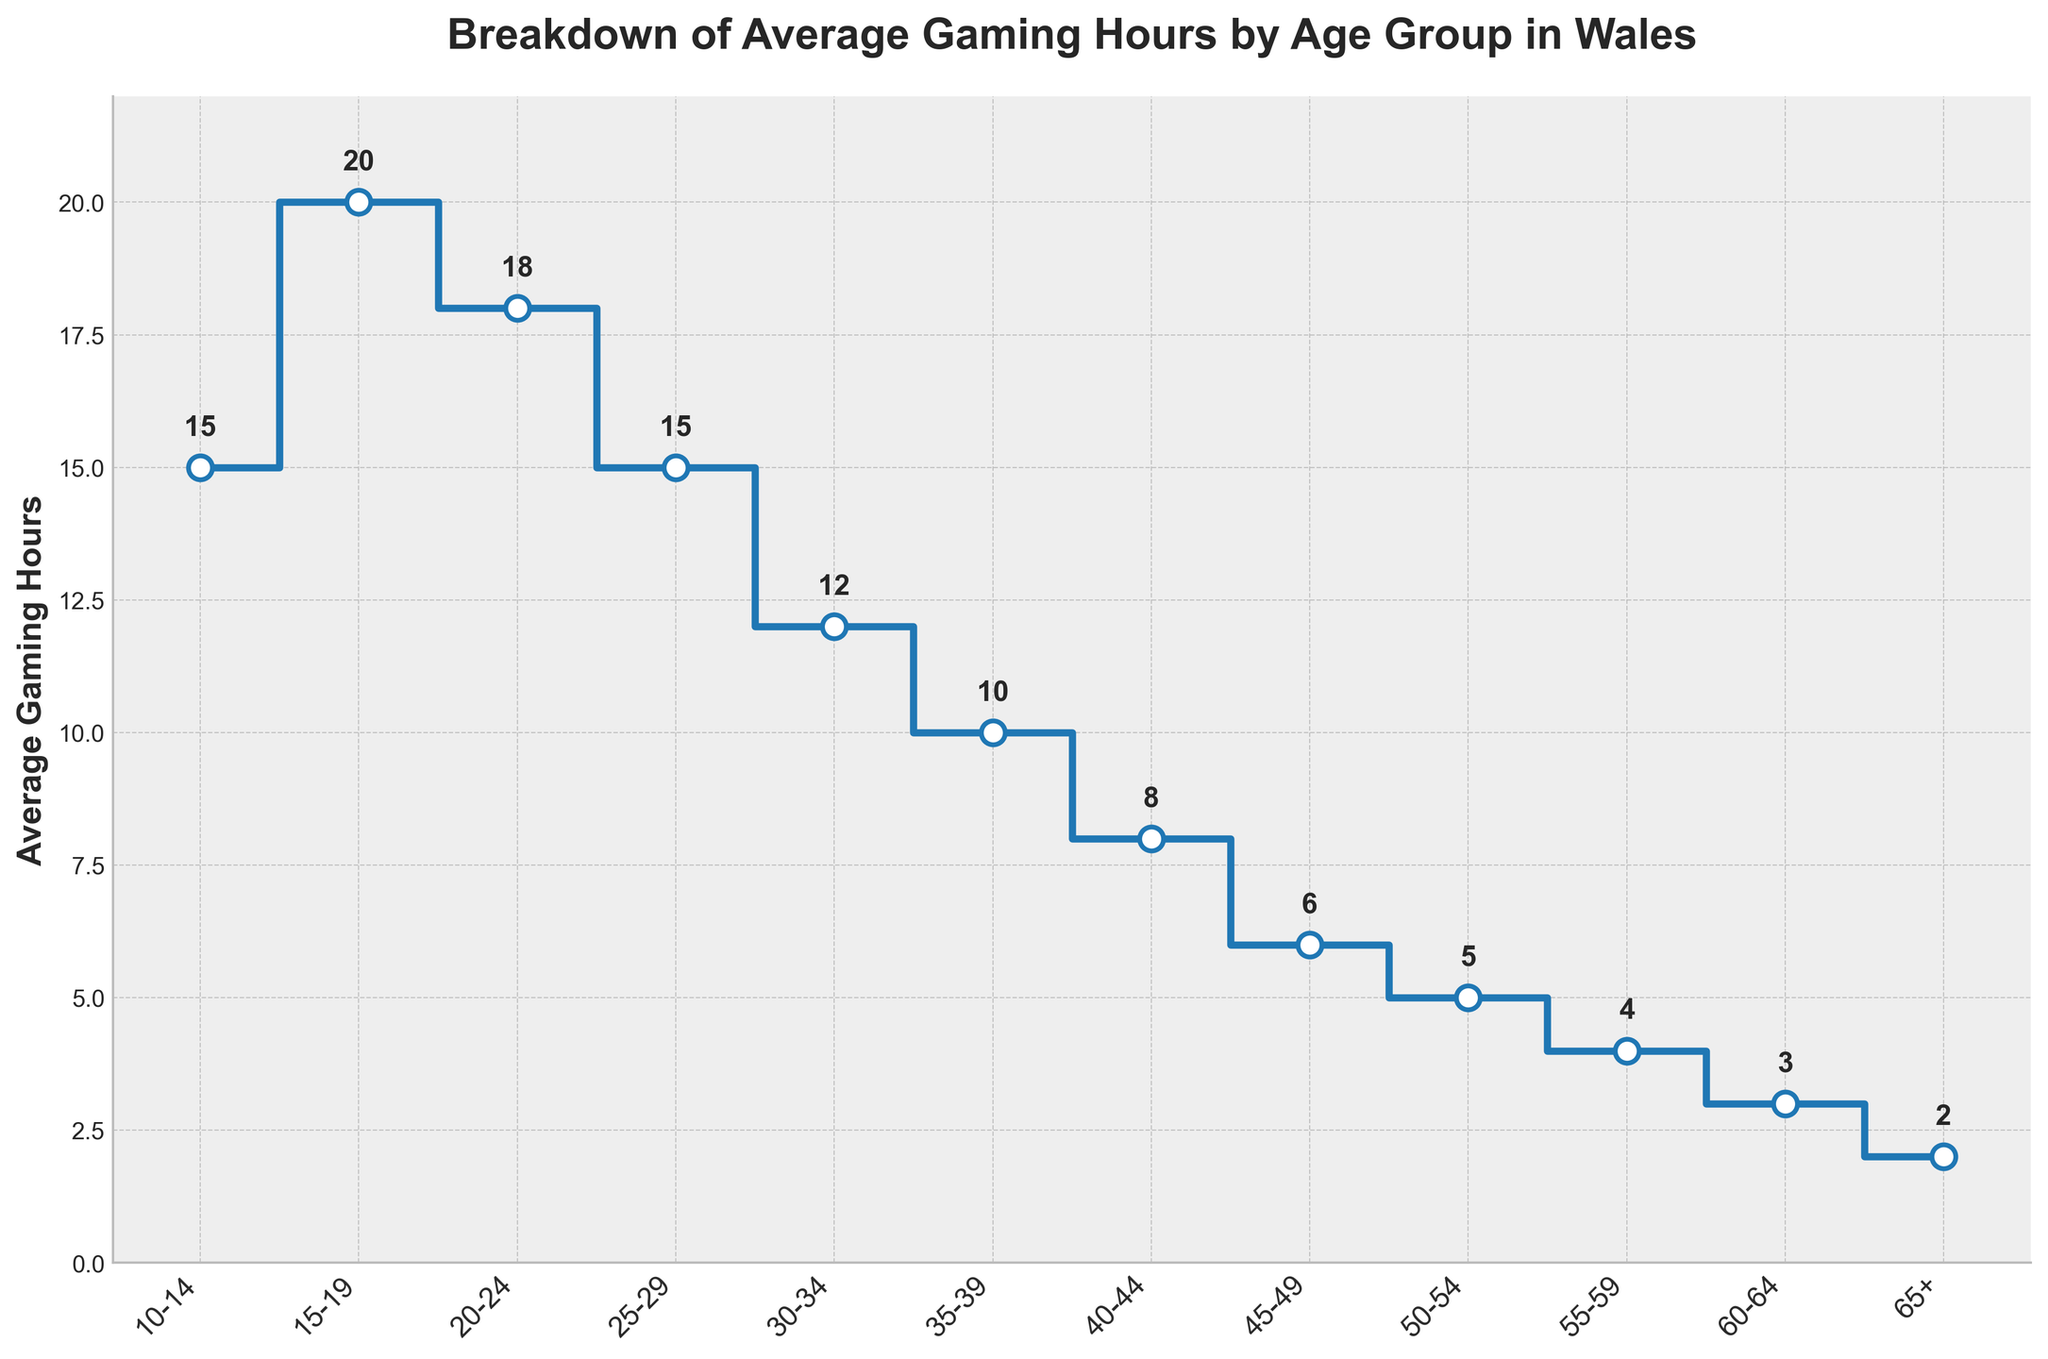What is the title of the plot? The title is usually found at the top of the plot and summarizes what the plot is about. From visual inspection, the title is "Breakdown of Average Gaming Hours by Age Group in Wales".
Answer: Breakdown of Average Gaming Hours by Age Group in Wales What is the maximum average gaming hours, and which age group does it correspond to? To find this, look at the highest point on the y-axis and trace it to the corresponding age group on the x-axis. The maximum value is 20 hours for the age group 15-19.
Answer: 20, 15-19 Which age group has the lowest average gaming hours? Look for the lowest data point on the y-axis and identify the corresponding age group on the x-axis. The lowest point is 2 hours for the age group 65+.
Answer: 65+ What is the difference in average gaming hours between the age groups 20-24 and 30-34? Look for the values corresponding to the age groups 20-24 and 30-34. The average gaming hours for 20-24 is 18 and for 30-34 is 12. The difference is 18 - 12 = 6 hours.
Answer: 6 Which age groups have an average gaming hours of 15? Identify the age groups whose y-values are 15. The age groups are 10-14 and 25-29.
Answer: 10-14, 25-29 How many age groups are there in total? Count the number of unique age groups listed on the x-axis. There are 12 age groups in total.
Answer: 12 What is the average gaming hours for the age group 55-59? Locate the value on the y-axis corresponding to the age group 55-59. The value is 4 hours.
Answer: 4 What is the sum of average gaming hours for the age groups 10-14, 15-19, and 20-24? Find the y-values for those age groups and sum them up. For 10-14: 15, for 15-19: 20, and for 20-24: 18. The sum is 15 + 20 + 18 = 53.
Answer: 53 How does the average gaming hours change as the age increases from 10-14 to 65+? Observe the general trend of the y-values as the x-values (age groups) progress from 10-14 to 65+. The average gaming hours generally decrease as age increases.
Answer: Decrease 